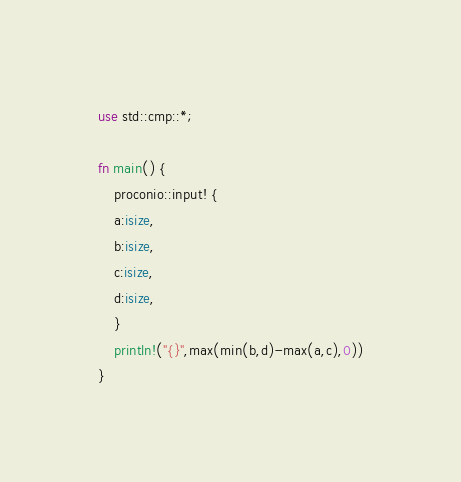Convert code to text. <code><loc_0><loc_0><loc_500><loc_500><_Rust_>use std::cmp::*;

fn main() {
    proconio::input! {
    a:isize,
    b:isize,
    c:isize,
    d:isize,
    }
    println!("{}",max(min(b,d)-max(a,c),0))
}</code> 